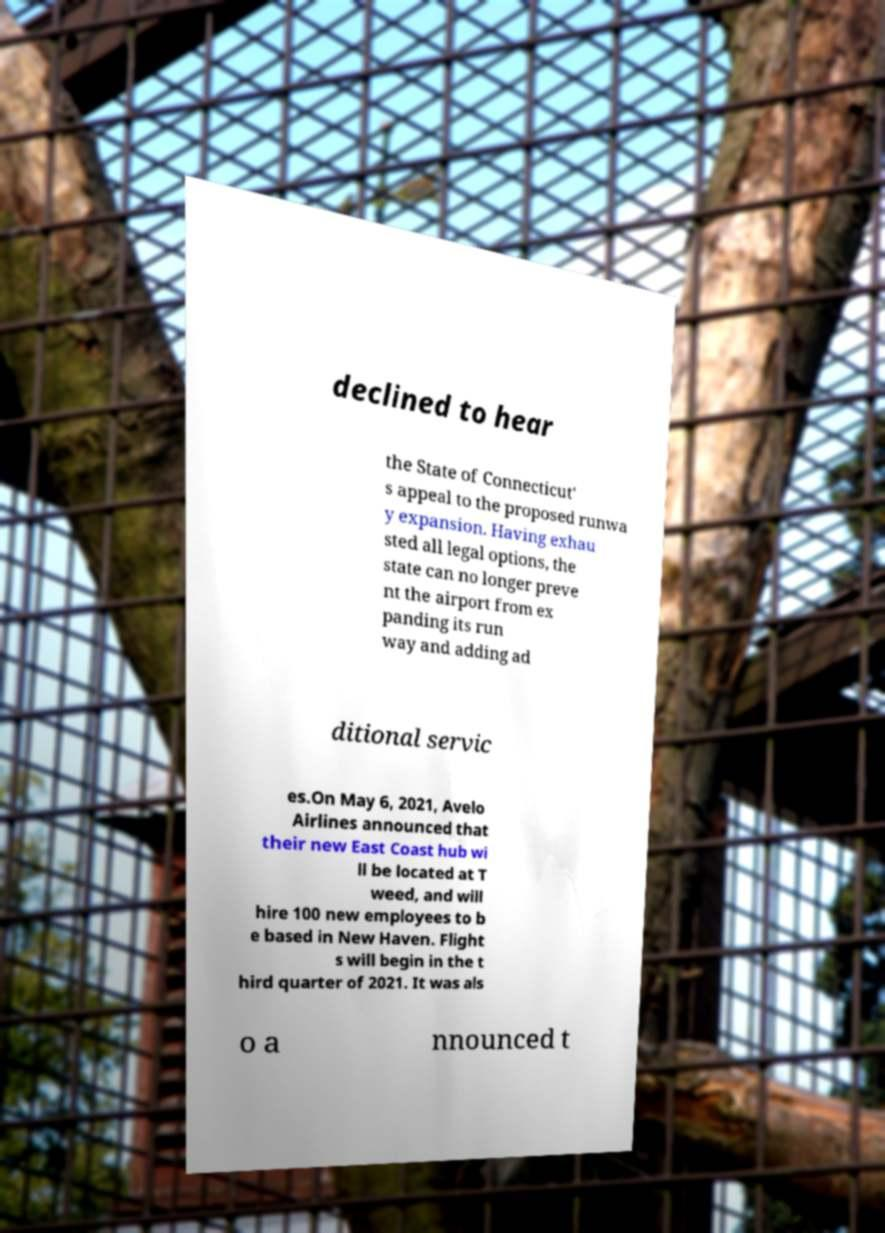I need the written content from this picture converted into text. Can you do that? declined to hear the State of Connecticut' s appeal to the proposed runwa y expansion. Having exhau sted all legal options, the state can no longer preve nt the airport from ex panding its run way and adding ad ditional servic es.On May 6, 2021, Avelo Airlines announced that their new East Coast hub wi ll be located at T weed, and will hire 100 new employees to b e based in New Haven. Flight s will begin in the t hird quarter of 2021. It was als o a nnounced t 